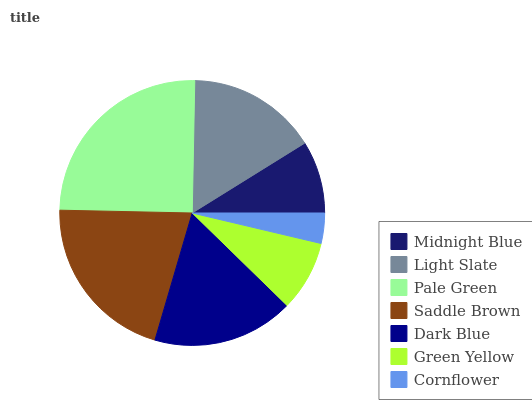Is Cornflower the minimum?
Answer yes or no. Yes. Is Pale Green the maximum?
Answer yes or no. Yes. Is Light Slate the minimum?
Answer yes or no. No. Is Light Slate the maximum?
Answer yes or no. No. Is Light Slate greater than Midnight Blue?
Answer yes or no. Yes. Is Midnight Blue less than Light Slate?
Answer yes or no. Yes. Is Midnight Blue greater than Light Slate?
Answer yes or no. No. Is Light Slate less than Midnight Blue?
Answer yes or no. No. Is Light Slate the high median?
Answer yes or no. Yes. Is Light Slate the low median?
Answer yes or no. Yes. Is Cornflower the high median?
Answer yes or no. No. Is Cornflower the low median?
Answer yes or no. No. 